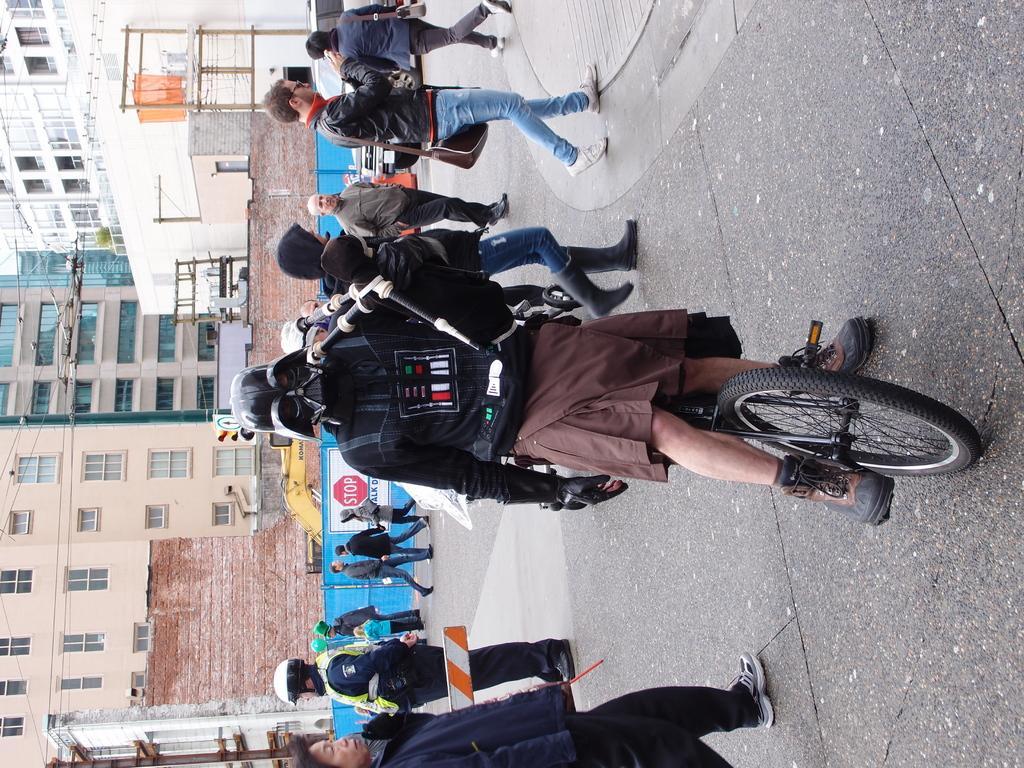Can you describe this image briefly? In this image I can see group of people. There are vehicles. buildings, electric poles and cables. 